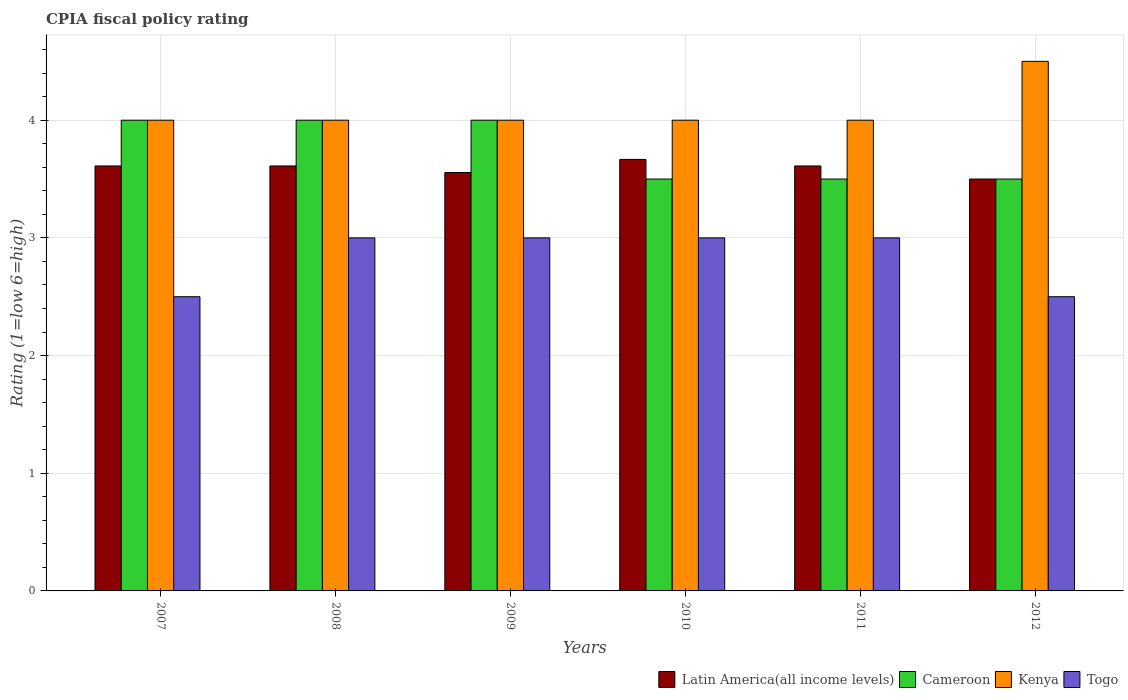Are the number of bars per tick equal to the number of legend labels?
Your response must be concise. Yes. Are the number of bars on each tick of the X-axis equal?
Offer a terse response. Yes. In how many cases, is the number of bars for a given year not equal to the number of legend labels?
Provide a short and direct response. 0. What is the CPIA rating in Kenya in 2009?
Provide a short and direct response. 4. Across all years, what is the maximum CPIA rating in Latin America(all income levels)?
Give a very brief answer. 3.67. In which year was the CPIA rating in Latin America(all income levels) maximum?
Your answer should be very brief. 2010. What is the total CPIA rating in Latin America(all income levels) in the graph?
Provide a short and direct response. 21.56. What is the average CPIA rating in Kenya per year?
Make the answer very short. 4.08. In the year 2009, what is the difference between the CPIA rating in Togo and CPIA rating in Kenya?
Your answer should be compact. -1. In how many years, is the CPIA rating in Kenya greater than 0.8?
Keep it short and to the point. 6. What is the ratio of the CPIA rating in Kenya in 2009 to that in 2012?
Offer a very short reply. 0.89. Is the difference between the CPIA rating in Togo in 2009 and 2011 greater than the difference between the CPIA rating in Kenya in 2009 and 2011?
Keep it short and to the point. No. What is the difference between the highest and the lowest CPIA rating in Togo?
Offer a very short reply. 0.5. In how many years, is the CPIA rating in Latin America(all income levels) greater than the average CPIA rating in Latin America(all income levels) taken over all years?
Keep it short and to the point. 4. Is the sum of the CPIA rating in Cameroon in 2009 and 2011 greater than the maximum CPIA rating in Togo across all years?
Your answer should be compact. Yes. Is it the case that in every year, the sum of the CPIA rating in Latin America(all income levels) and CPIA rating in Kenya is greater than the sum of CPIA rating in Cameroon and CPIA rating in Togo?
Keep it short and to the point. No. What does the 1st bar from the left in 2010 represents?
Give a very brief answer. Latin America(all income levels). What does the 3rd bar from the right in 2007 represents?
Offer a terse response. Cameroon. What is the difference between two consecutive major ticks on the Y-axis?
Your answer should be very brief. 1. Are the values on the major ticks of Y-axis written in scientific E-notation?
Provide a succinct answer. No. Does the graph contain any zero values?
Provide a short and direct response. No. Where does the legend appear in the graph?
Provide a short and direct response. Bottom right. How many legend labels are there?
Offer a terse response. 4. How are the legend labels stacked?
Keep it short and to the point. Horizontal. What is the title of the graph?
Provide a short and direct response. CPIA fiscal policy rating. What is the Rating (1=low 6=high) in Latin America(all income levels) in 2007?
Your answer should be very brief. 3.61. What is the Rating (1=low 6=high) of Cameroon in 2007?
Keep it short and to the point. 4. What is the Rating (1=low 6=high) in Kenya in 2007?
Your answer should be compact. 4. What is the Rating (1=low 6=high) in Togo in 2007?
Give a very brief answer. 2.5. What is the Rating (1=low 6=high) of Latin America(all income levels) in 2008?
Your answer should be very brief. 3.61. What is the Rating (1=low 6=high) in Togo in 2008?
Your answer should be compact. 3. What is the Rating (1=low 6=high) of Latin America(all income levels) in 2009?
Offer a terse response. 3.56. What is the Rating (1=low 6=high) of Cameroon in 2009?
Provide a short and direct response. 4. What is the Rating (1=low 6=high) in Togo in 2009?
Offer a very short reply. 3. What is the Rating (1=low 6=high) in Latin America(all income levels) in 2010?
Your answer should be compact. 3.67. What is the Rating (1=low 6=high) of Cameroon in 2010?
Your response must be concise. 3.5. What is the Rating (1=low 6=high) in Togo in 2010?
Your response must be concise. 3. What is the Rating (1=low 6=high) in Latin America(all income levels) in 2011?
Keep it short and to the point. 3.61. What is the Rating (1=low 6=high) in Cameroon in 2011?
Offer a terse response. 3.5. What is the Rating (1=low 6=high) of Kenya in 2011?
Give a very brief answer. 4. What is the Rating (1=low 6=high) in Latin America(all income levels) in 2012?
Your answer should be compact. 3.5. What is the Rating (1=low 6=high) in Togo in 2012?
Your response must be concise. 2.5. Across all years, what is the maximum Rating (1=low 6=high) in Latin America(all income levels)?
Your answer should be compact. 3.67. Across all years, what is the maximum Rating (1=low 6=high) of Kenya?
Give a very brief answer. 4.5. Across all years, what is the minimum Rating (1=low 6=high) of Latin America(all income levels)?
Provide a short and direct response. 3.5. Across all years, what is the minimum Rating (1=low 6=high) of Togo?
Offer a very short reply. 2.5. What is the total Rating (1=low 6=high) in Latin America(all income levels) in the graph?
Your answer should be very brief. 21.56. What is the total Rating (1=low 6=high) of Kenya in the graph?
Your answer should be very brief. 24.5. What is the total Rating (1=low 6=high) of Togo in the graph?
Make the answer very short. 17. What is the difference between the Rating (1=low 6=high) of Latin America(all income levels) in 2007 and that in 2008?
Ensure brevity in your answer.  0. What is the difference between the Rating (1=low 6=high) in Cameroon in 2007 and that in 2008?
Keep it short and to the point. 0. What is the difference between the Rating (1=low 6=high) of Kenya in 2007 and that in 2008?
Your answer should be very brief. 0. What is the difference between the Rating (1=low 6=high) in Latin America(all income levels) in 2007 and that in 2009?
Offer a terse response. 0.06. What is the difference between the Rating (1=low 6=high) in Kenya in 2007 and that in 2009?
Keep it short and to the point. 0. What is the difference between the Rating (1=low 6=high) of Latin America(all income levels) in 2007 and that in 2010?
Make the answer very short. -0.06. What is the difference between the Rating (1=low 6=high) of Togo in 2007 and that in 2010?
Your answer should be compact. -0.5. What is the difference between the Rating (1=low 6=high) of Latin America(all income levels) in 2007 and that in 2011?
Your answer should be very brief. 0. What is the difference between the Rating (1=low 6=high) of Kenya in 2007 and that in 2011?
Your answer should be very brief. 0. What is the difference between the Rating (1=low 6=high) in Togo in 2007 and that in 2011?
Give a very brief answer. -0.5. What is the difference between the Rating (1=low 6=high) in Cameroon in 2007 and that in 2012?
Offer a very short reply. 0.5. What is the difference between the Rating (1=low 6=high) of Togo in 2007 and that in 2012?
Your response must be concise. 0. What is the difference between the Rating (1=low 6=high) of Latin America(all income levels) in 2008 and that in 2009?
Keep it short and to the point. 0.06. What is the difference between the Rating (1=low 6=high) in Latin America(all income levels) in 2008 and that in 2010?
Ensure brevity in your answer.  -0.06. What is the difference between the Rating (1=low 6=high) of Cameroon in 2008 and that in 2010?
Provide a short and direct response. 0.5. What is the difference between the Rating (1=low 6=high) of Togo in 2008 and that in 2010?
Provide a succinct answer. 0. What is the difference between the Rating (1=low 6=high) of Latin America(all income levels) in 2008 and that in 2011?
Offer a terse response. 0. What is the difference between the Rating (1=low 6=high) in Cameroon in 2008 and that in 2011?
Your answer should be compact. 0.5. What is the difference between the Rating (1=low 6=high) of Kenya in 2008 and that in 2011?
Your answer should be compact. 0. What is the difference between the Rating (1=low 6=high) of Kenya in 2008 and that in 2012?
Provide a succinct answer. -0.5. What is the difference between the Rating (1=low 6=high) in Togo in 2008 and that in 2012?
Provide a short and direct response. 0.5. What is the difference between the Rating (1=low 6=high) in Latin America(all income levels) in 2009 and that in 2010?
Your response must be concise. -0.11. What is the difference between the Rating (1=low 6=high) of Cameroon in 2009 and that in 2010?
Your response must be concise. 0.5. What is the difference between the Rating (1=low 6=high) in Kenya in 2009 and that in 2010?
Give a very brief answer. 0. What is the difference between the Rating (1=low 6=high) in Togo in 2009 and that in 2010?
Provide a succinct answer. 0. What is the difference between the Rating (1=low 6=high) of Latin America(all income levels) in 2009 and that in 2011?
Provide a succinct answer. -0.06. What is the difference between the Rating (1=low 6=high) in Latin America(all income levels) in 2009 and that in 2012?
Your response must be concise. 0.06. What is the difference between the Rating (1=low 6=high) of Kenya in 2009 and that in 2012?
Make the answer very short. -0.5. What is the difference between the Rating (1=low 6=high) in Togo in 2009 and that in 2012?
Keep it short and to the point. 0.5. What is the difference between the Rating (1=low 6=high) in Latin America(all income levels) in 2010 and that in 2011?
Offer a terse response. 0.06. What is the difference between the Rating (1=low 6=high) in Cameroon in 2010 and that in 2011?
Provide a succinct answer. 0. What is the difference between the Rating (1=low 6=high) of Cameroon in 2010 and that in 2012?
Your answer should be compact. 0. What is the difference between the Rating (1=low 6=high) of Cameroon in 2011 and that in 2012?
Provide a short and direct response. 0. What is the difference between the Rating (1=low 6=high) of Kenya in 2011 and that in 2012?
Offer a very short reply. -0.5. What is the difference between the Rating (1=low 6=high) in Togo in 2011 and that in 2012?
Keep it short and to the point. 0.5. What is the difference between the Rating (1=low 6=high) in Latin America(all income levels) in 2007 and the Rating (1=low 6=high) in Cameroon in 2008?
Offer a very short reply. -0.39. What is the difference between the Rating (1=low 6=high) in Latin America(all income levels) in 2007 and the Rating (1=low 6=high) in Kenya in 2008?
Make the answer very short. -0.39. What is the difference between the Rating (1=low 6=high) in Latin America(all income levels) in 2007 and the Rating (1=low 6=high) in Togo in 2008?
Offer a terse response. 0.61. What is the difference between the Rating (1=low 6=high) in Cameroon in 2007 and the Rating (1=low 6=high) in Kenya in 2008?
Ensure brevity in your answer.  0. What is the difference between the Rating (1=low 6=high) in Latin America(all income levels) in 2007 and the Rating (1=low 6=high) in Cameroon in 2009?
Your answer should be compact. -0.39. What is the difference between the Rating (1=low 6=high) of Latin America(all income levels) in 2007 and the Rating (1=low 6=high) of Kenya in 2009?
Your response must be concise. -0.39. What is the difference between the Rating (1=low 6=high) in Latin America(all income levels) in 2007 and the Rating (1=low 6=high) in Togo in 2009?
Your answer should be very brief. 0.61. What is the difference between the Rating (1=low 6=high) in Cameroon in 2007 and the Rating (1=low 6=high) in Togo in 2009?
Your answer should be compact. 1. What is the difference between the Rating (1=low 6=high) in Latin America(all income levels) in 2007 and the Rating (1=low 6=high) in Cameroon in 2010?
Your answer should be very brief. 0.11. What is the difference between the Rating (1=low 6=high) in Latin America(all income levels) in 2007 and the Rating (1=low 6=high) in Kenya in 2010?
Make the answer very short. -0.39. What is the difference between the Rating (1=low 6=high) in Latin America(all income levels) in 2007 and the Rating (1=low 6=high) in Togo in 2010?
Make the answer very short. 0.61. What is the difference between the Rating (1=low 6=high) in Kenya in 2007 and the Rating (1=low 6=high) in Togo in 2010?
Provide a short and direct response. 1. What is the difference between the Rating (1=low 6=high) in Latin America(all income levels) in 2007 and the Rating (1=low 6=high) in Kenya in 2011?
Offer a very short reply. -0.39. What is the difference between the Rating (1=low 6=high) of Latin America(all income levels) in 2007 and the Rating (1=low 6=high) of Togo in 2011?
Your response must be concise. 0.61. What is the difference between the Rating (1=low 6=high) of Kenya in 2007 and the Rating (1=low 6=high) of Togo in 2011?
Your response must be concise. 1. What is the difference between the Rating (1=low 6=high) in Latin America(all income levels) in 2007 and the Rating (1=low 6=high) in Kenya in 2012?
Offer a terse response. -0.89. What is the difference between the Rating (1=low 6=high) in Cameroon in 2007 and the Rating (1=low 6=high) in Togo in 2012?
Provide a succinct answer. 1.5. What is the difference between the Rating (1=low 6=high) of Kenya in 2007 and the Rating (1=low 6=high) of Togo in 2012?
Your answer should be compact. 1.5. What is the difference between the Rating (1=low 6=high) of Latin America(all income levels) in 2008 and the Rating (1=low 6=high) of Cameroon in 2009?
Give a very brief answer. -0.39. What is the difference between the Rating (1=low 6=high) in Latin America(all income levels) in 2008 and the Rating (1=low 6=high) in Kenya in 2009?
Provide a succinct answer. -0.39. What is the difference between the Rating (1=low 6=high) in Latin America(all income levels) in 2008 and the Rating (1=low 6=high) in Togo in 2009?
Give a very brief answer. 0.61. What is the difference between the Rating (1=low 6=high) in Latin America(all income levels) in 2008 and the Rating (1=low 6=high) in Cameroon in 2010?
Your answer should be compact. 0.11. What is the difference between the Rating (1=low 6=high) in Latin America(all income levels) in 2008 and the Rating (1=low 6=high) in Kenya in 2010?
Make the answer very short. -0.39. What is the difference between the Rating (1=low 6=high) in Latin America(all income levels) in 2008 and the Rating (1=low 6=high) in Togo in 2010?
Offer a terse response. 0.61. What is the difference between the Rating (1=low 6=high) in Cameroon in 2008 and the Rating (1=low 6=high) in Kenya in 2010?
Provide a succinct answer. 0. What is the difference between the Rating (1=low 6=high) of Cameroon in 2008 and the Rating (1=low 6=high) of Togo in 2010?
Your answer should be compact. 1. What is the difference between the Rating (1=low 6=high) in Kenya in 2008 and the Rating (1=low 6=high) in Togo in 2010?
Offer a very short reply. 1. What is the difference between the Rating (1=low 6=high) of Latin America(all income levels) in 2008 and the Rating (1=low 6=high) of Kenya in 2011?
Provide a short and direct response. -0.39. What is the difference between the Rating (1=low 6=high) in Latin America(all income levels) in 2008 and the Rating (1=low 6=high) in Togo in 2011?
Ensure brevity in your answer.  0.61. What is the difference between the Rating (1=low 6=high) in Cameroon in 2008 and the Rating (1=low 6=high) in Togo in 2011?
Your answer should be very brief. 1. What is the difference between the Rating (1=low 6=high) in Latin America(all income levels) in 2008 and the Rating (1=low 6=high) in Kenya in 2012?
Provide a succinct answer. -0.89. What is the difference between the Rating (1=low 6=high) in Cameroon in 2008 and the Rating (1=low 6=high) in Kenya in 2012?
Provide a short and direct response. -0.5. What is the difference between the Rating (1=low 6=high) in Latin America(all income levels) in 2009 and the Rating (1=low 6=high) in Cameroon in 2010?
Offer a terse response. 0.06. What is the difference between the Rating (1=low 6=high) in Latin America(all income levels) in 2009 and the Rating (1=low 6=high) in Kenya in 2010?
Offer a very short reply. -0.44. What is the difference between the Rating (1=low 6=high) of Latin America(all income levels) in 2009 and the Rating (1=low 6=high) of Togo in 2010?
Provide a short and direct response. 0.56. What is the difference between the Rating (1=low 6=high) in Cameroon in 2009 and the Rating (1=low 6=high) in Togo in 2010?
Your answer should be very brief. 1. What is the difference between the Rating (1=low 6=high) of Kenya in 2009 and the Rating (1=low 6=high) of Togo in 2010?
Ensure brevity in your answer.  1. What is the difference between the Rating (1=low 6=high) of Latin America(all income levels) in 2009 and the Rating (1=low 6=high) of Cameroon in 2011?
Make the answer very short. 0.06. What is the difference between the Rating (1=low 6=high) in Latin America(all income levels) in 2009 and the Rating (1=low 6=high) in Kenya in 2011?
Provide a succinct answer. -0.44. What is the difference between the Rating (1=low 6=high) of Latin America(all income levels) in 2009 and the Rating (1=low 6=high) of Togo in 2011?
Ensure brevity in your answer.  0.56. What is the difference between the Rating (1=low 6=high) of Cameroon in 2009 and the Rating (1=low 6=high) of Kenya in 2011?
Make the answer very short. 0. What is the difference between the Rating (1=low 6=high) of Cameroon in 2009 and the Rating (1=low 6=high) of Togo in 2011?
Your answer should be very brief. 1. What is the difference between the Rating (1=low 6=high) in Kenya in 2009 and the Rating (1=low 6=high) in Togo in 2011?
Offer a very short reply. 1. What is the difference between the Rating (1=low 6=high) in Latin America(all income levels) in 2009 and the Rating (1=low 6=high) in Cameroon in 2012?
Make the answer very short. 0.06. What is the difference between the Rating (1=low 6=high) of Latin America(all income levels) in 2009 and the Rating (1=low 6=high) of Kenya in 2012?
Give a very brief answer. -0.94. What is the difference between the Rating (1=low 6=high) of Latin America(all income levels) in 2009 and the Rating (1=low 6=high) of Togo in 2012?
Provide a succinct answer. 1.06. What is the difference between the Rating (1=low 6=high) of Cameroon in 2009 and the Rating (1=low 6=high) of Togo in 2012?
Your answer should be very brief. 1.5. What is the difference between the Rating (1=low 6=high) of Kenya in 2009 and the Rating (1=low 6=high) of Togo in 2012?
Keep it short and to the point. 1.5. What is the difference between the Rating (1=low 6=high) of Latin America(all income levels) in 2010 and the Rating (1=low 6=high) of Cameroon in 2011?
Ensure brevity in your answer.  0.17. What is the difference between the Rating (1=low 6=high) in Latin America(all income levels) in 2010 and the Rating (1=low 6=high) in Kenya in 2011?
Make the answer very short. -0.33. What is the difference between the Rating (1=low 6=high) of Cameroon in 2010 and the Rating (1=low 6=high) of Kenya in 2011?
Make the answer very short. -0.5. What is the difference between the Rating (1=low 6=high) of Latin America(all income levels) in 2010 and the Rating (1=low 6=high) of Kenya in 2012?
Provide a short and direct response. -0.83. What is the difference between the Rating (1=low 6=high) in Latin America(all income levels) in 2010 and the Rating (1=low 6=high) in Togo in 2012?
Ensure brevity in your answer.  1.17. What is the difference between the Rating (1=low 6=high) in Kenya in 2010 and the Rating (1=low 6=high) in Togo in 2012?
Your response must be concise. 1.5. What is the difference between the Rating (1=low 6=high) in Latin America(all income levels) in 2011 and the Rating (1=low 6=high) in Cameroon in 2012?
Your response must be concise. 0.11. What is the difference between the Rating (1=low 6=high) of Latin America(all income levels) in 2011 and the Rating (1=low 6=high) of Kenya in 2012?
Provide a short and direct response. -0.89. What is the difference between the Rating (1=low 6=high) of Cameroon in 2011 and the Rating (1=low 6=high) of Kenya in 2012?
Keep it short and to the point. -1. What is the average Rating (1=low 6=high) in Latin America(all income levels) per year?
Offer a terse response. 3.59. What is the average Rating (1=low 6=high) in Cameroon per year?
Keep it short and to the point. 3.75. What is the average Rating (1=low 6=high) in Kenya per year?
Your response must be concise. 4.08. What is the average Rating (1=low 6=high) in Togo per year?
Ensure brevity in your answer.  2.83. In the year 2007, what is the difference between the Rating (1=low 6=high) of Latin America(all income levels) and Rating (1=low 6=high) of Cameroon?
Keep it short and to the point. -0.39. In the year 2007, what is the difference between the Rating (1=low 6=high) in Latin America(all income levels) and Rating (1=low 6=high) in Kenya?
Keep it short and to the point. -0.39. In the year 2008, what is the difference between the Rating (1=low 6=high) of Latin America(all income levels) and Rating (1=low 6=high) of Cameroon?
Keep it short and to the point. -0.39. In the year 2008, what is the difference between the Rating (1=low 6=high) in Latin America(all income levels) and Rating (1=low 6=high) in Kenya?
Provide a succinct answer. -0.39. In the year 2008, what is the difference between the Rating (1=low 6=high) of Latin America(all income levels) and Rating (1=low 6=high) of Togo?
Offer a very short reply. 0.61. In the year 2008, what is the difference between the Rating (1=low 6=high) of Cameroon and Rating (1=low 6=high) of Kenya?
Offer a very short reply. 0. In the year 2008, what is the difference between the Rating (1=low 6=high) in Cameroon and Rating (1=low 6=high) in Togo?
Provide a short and direct response. 1. In the year 2009, what is the difference between the Rating (1=low 6=high) in Latin America(all income levels) and Rating (1=low 6=high) in Cameroon?
Provide a short and direct response. -0.44. In the year 2009, what is the difference between the Rating (1=low 6=high) of Latin America(all income levels) and Rating (1=low 6=high) of Kenya?
Offer a terse response. -0.44. In the year 2009, what is the difference between the Rating (1=low 6=high) in Latin America(all income levels) and Rating (1=low 6=high) in Togo?
Ensure brevity in your answer.  0.56. In the year 2010, what is the difference between the Rating (1=low 6=high) of Latin America(all income levels) and Rating (1=low 6=high) of Cameroon?
Keep it short and to the point. 0.17. In the year 2010, what is the difference between the Rating (1=low 6=high) of Kenya and Rating (1=low 6=high) of Togo?
Offer a terse response. 1. In the year 2011, what is the difference between the Rating (1=low 6=high) in Latin America(all income levels) and Rating (1=low 6=high) in Kenya?
Your answer should be very brief. -0.39. In the year 2011, what is the difference between the Rating (1=low 6=high) of Latin America(all income levels) and Rating (1=low 6=high) of Togo?
Provide a succinct answer. 0.61. In the year 2011, what is the difference between the Rating (1=low 6=high) of Cameroon and Rating (1=low 6=high) of Kenya?
Provide a short and direct response. -0.5. In the year 2011, what is the difference between the Rating (1=low 6=high) of Cameroon and Rating (1=low 6=high) of Togo?
Provide a short and direct response. 0.5. In the year 2011, what is the difference between the Rating (1=low 6=high) of Kenya and Rating (1=low 6=high) of Togo?
Provide a succinct answer. 1. In the year 2012, what is the difference between the Rating (1=low 6=high) of Latin America(all income levels) and Rating (1=low 6=high) of Cameroon?
Ensure brevity in your answer.  0. In the year 2012, what is the difference between the Rating (1=low 6=high) in Latin America(all income levels) and Rating (1=low 6=high) in Togo?
Give a very brief answer. 1. In the year 2012, what is the difference between the Rating (1=low 6=high) of Cameroon and Rating (1=low 6=high) of Kenya?
Keep it short and to the point. -1. In the year 2012, what is the difference between the Rating (1=low 6=high) of Cameroon and Rating (1=low 6=high) of Togo?
Provide a succinct answer. 1. In the year 2012, what is the difference between the Rating (1=low 6=high) in Kenya and Rating (1=low 6=high) in Togo?
Your answer should be compact. 2. What is the ratio of the Rating (1=low 6=high) of Latin America(all income levels) in 2007 to that in 2008?
Ensure brevity in your answer.  1. What is the ratio of the Rating (1=low 6=high) of Cameroon in 2007 to that in 2008?
Your answer should be very brief. 1. What is the ratio of the Rating (1=low 6=high) of Togo in 2007 to that in 2008?
Your answer should be compact. 0.83. What is the ratio of the Rating (1=low 6=high) in Latin America(all income levels) in 2007 to that in 2009?
Offer a very short reply. 1.02. What is the ratio of the Rating (1=low 6=high) in Cameroon in 2007 to that in 2009?
Ensure brevity in your answer.  1. What is the ratio of the Rating (1=low 6=high) in Latin America(all income levels) in 2007 to that in 2010?
Make the answer very short. 0.98. What is the ratio of the Rating (1=low 6=high) of Cameroon in 2007 to that in 2010?
Provide a short and direct response. 1.14. What is the ratio of the Rating (1=low 6=high) in Kenya in 2007 to that in 2010?
Your answer should be compact. 1. What is the ratio of the Rating (1=low 6=high) in Togo in 2007 to that in 2010?
Ensure brevity in your answer.  0.83. What is the ratio of the Rating (1=low 6=high) in Latin America(all income levels) in 2007 to that in 2011?
Offer a terse response. 1. What is the ratio of the Rating (1=low 6=high) of Cameroon in 2007 to that in 2011?
Keep it short and to the point. 1.14. What is the ratio of the Rating (1=low 6=high) in Togo in 2007 to that in 2011?
Ensure brevity in your answer.  0.83. What is the ratio of the Rating (1=low 6=high) of Latin America(all income levels) in 2007 to that in 2012?
Provide a short and direct response. 1.03. What is the ratio of the Rating (1=low 6=high) of Cameroon in 2007 to that in 2012?
Your answer should be very brief. 1.14. What is the ratio of the Rating (1=low 6=high) of Togo in 2007 to that in 2012?
Your answer should be very brief. 1. What is the ratio of the Rating (1=low 6=high) in Latin America(all income levels) in 2008 to that in 2009?
Give a very brief answer. 1.02. What is the ratio of the Rating (1=low 6=high) in Cameroon in 2008 to that in 2009?
Your answer should be very brief. 1. What is the ratio of the Rating (1=low 6=high) in Kenya in 2008 to that in 2009?
Keep it short and to the point. 1. What is the ratio of the Rating (1=low 6=high) of Cameroon in 2008 to that in 2010?
Give a very brief answer. 1.14. What is the ratio of the Rating (1=low 6=high) of Kenya in 2008 to that in 2011?
Provide a succinct answer. 1. What is the ratio of the Rating (1=low 6=high) of Togo in 2008 to that in 2011?
Keep it short and to the point. 1. What is the ratio of the Rating (1=low 6=high) of Latin America(all income levels) in 2008 to that in 2012?
Give a very brief answer. 1.03. What is the ratio of the Rating (1=low 6=high) of Latin America(all income levels) in 2009 to that in 2010?
Make the answer very short. 0.97. What is the ratio of the Rating (1=low 6=high) of Latin America(all income levels) in 2009 to that in 2011?
Offer a terse response. 0.98. What is the ratio of the Rating (1=low 6=high) of Cameroon in 2009 to that in 2011?
Offer a very short reply. 1.14. What is the ratio of the Rating (1=low 6=high) in Togo in 2009 to that in 2011?
Give a very brief answer. 1. What is the ratio of the Rating (1=low 6=high) in Latin America(all income levels) in 2009 to that in 2012?
Provide a succinct answer. 1.02. What is the ratio of the Rating (1=low 6=high) in Kenya in 2009 to that in 2012?
Ensure brevity in your answer.  0.89. What is the ratio of the Rating (1=low 6=high) in Togo in 2009 to that in 2012?
Your response must be concise. 1.2. What is the ratio of the Rating (1=low 6=high) in Latin America(all income levels) in 2010 to that in 2011?
Keep it short and to the point. 1.02. What is the ratio of the Rating (1=low 6=high) in Cameroon in 2010 to that in 2011?
Provide a short and direct response. 1. What is the ratio of the Rating (1=low 6=high) in Kenya in 2010 to that in 2011?
Ensure brevity in your answer.  1. What is the ratio of the Rating (1=low 6=high) of Latin America(all income levels) in 2010 to that in 2012?
Offer a very short reply. 1.05. What is the ratio of the Rating (1=low 6=high) in Cameroon in 2010 to that in 2012?
Provide a short and direct response. 1. What is the ratio of the Rating (1=low 6=high) in Kenya in 2010 to that in 2012?
Keep it short and to the point. 0.89. What is the ratio of the Rating (1=low 6=high) of Latin America(all income levels) in 2011 to that in 2012?
Keep it short and to the point. 1.03. What is the difference between the highest and the second highest Rating (1=low 6=high) in Latin America(all income levels)?
Offer a terse response. 0.06. What is the difference between the highest and the second highest Rating (1=low 6=high) in Cameroon?
Ensure brevity in your answer.  0. What is the difference between the highest and the second highest Rating (1=low 6=high) of Kenya?
Provide a short and direct response. 0.5. 